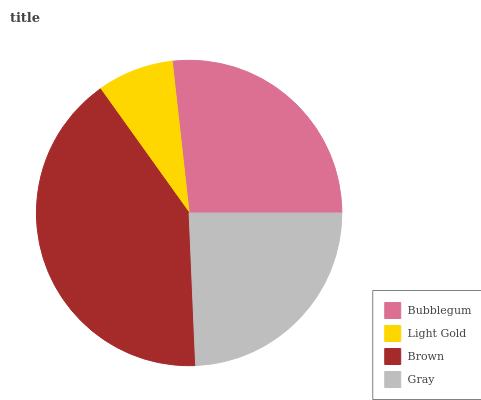Is Light Gold the minimum?
Answer yes or no. Yes. Is Brown the maximum?
Answer yes or no. Yes. Is Brown the minimum?
Answer yes or no. No. Is Light Gold the maximum?
Answer yes or no. No. Is Brown greater than Light Gold?
Answer yes or no. Yes. Is Light Gold less than Brown?
Answer yes or no. Yes. Is Light Gold greater than Brown?
Answer yes or no. No. Is Brown less than Light Gold?
Answer yes or no. No. Is Bubblegum the high median?
Answer yes or no. Yes. Is Gray the low median?
Answer yes or no. Yes. Is Light Gold the high median?
Answer yes or no. No. Is Brown the low median?
Answer yes or no. No. 